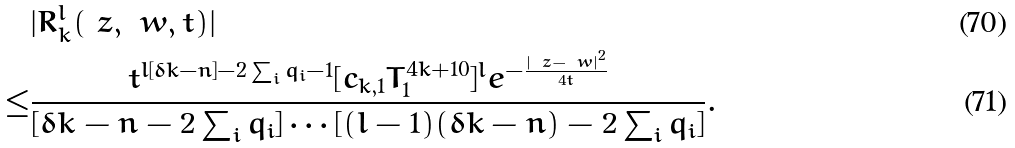Convert formula to latex. <formula><loc_0><loc_0><loc_500><loc_500>& | R ^ { l } _ { k } ( \ z , \ w , t ) | \\ \leq & \frac { t ^ { l [ \delta k - n ] - 2 \sum _ { i } q _ { i } - 1 } [ c _ { k , 1 } T _ { 1 } ^ { 4 k + 1 0 } ] ^ { l } e ^ { - \frac { | \ z - \ w | ^ { 2 } } { 4 t } } } { [ \delta k - n - 2 \sum _ { i } q _ { i } ] \cdots [ ( l - 1 ) ( \delta k - n ) - 2 \sum _ { i } q _ { i } ] } .</formula> 